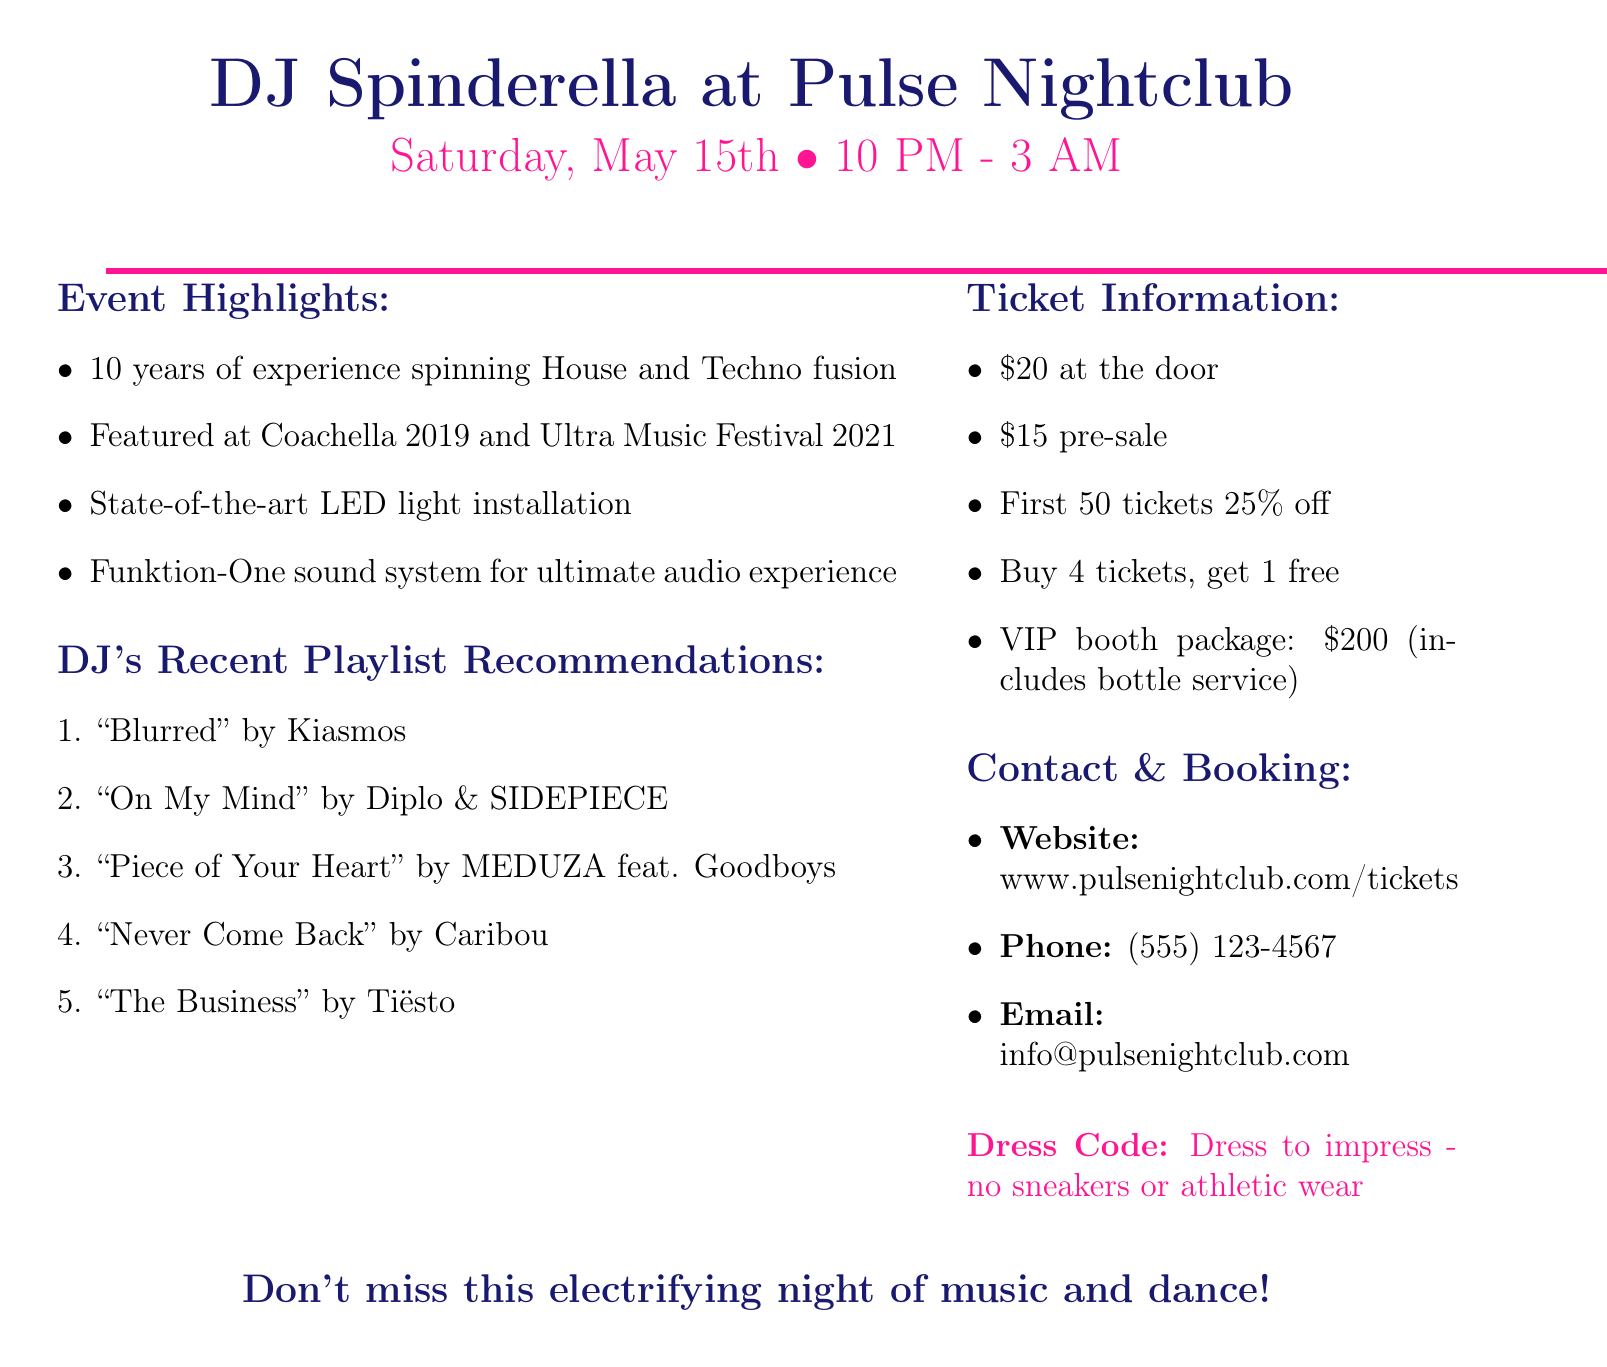What is the DJ's name? The document mentions the DJ as DJ Spinderella.
Answer: DJ Spinderella What is the venue name? The venue for the gig is specified as Pulse Nightclub.
Answer: Pulse Nightclub When does the event take place? The date of the event is listed as Saturday, May 15th.
Answer: Saturday, May 15th What is the ticket price at the door? The document states that the ticket price at the door is $20.
Answer: $20 What music style does DJ Spinderella perform? The document describes the DJ's music style as House and Techno fusion.
Answer: House and Techno fusion How many years of experience does the DJ have? The DJ has 10 years of experience according to the document.
Answer: 10 years What is the group discount offer? The document offers a group discount where buying 4 tickets gets you 1 free.
Answer: Buy 4 tickets, get 1 free What special audio system is mentioned? The document highlights the use of a Funktion-One sound system.
Answer: Funktion-One sound system Is there a dress code for the event? Yes, the dress code states to dress to impress with no sneakers or athletic wear.
Answer: Dress to impress - no sneakers or athletic wear 